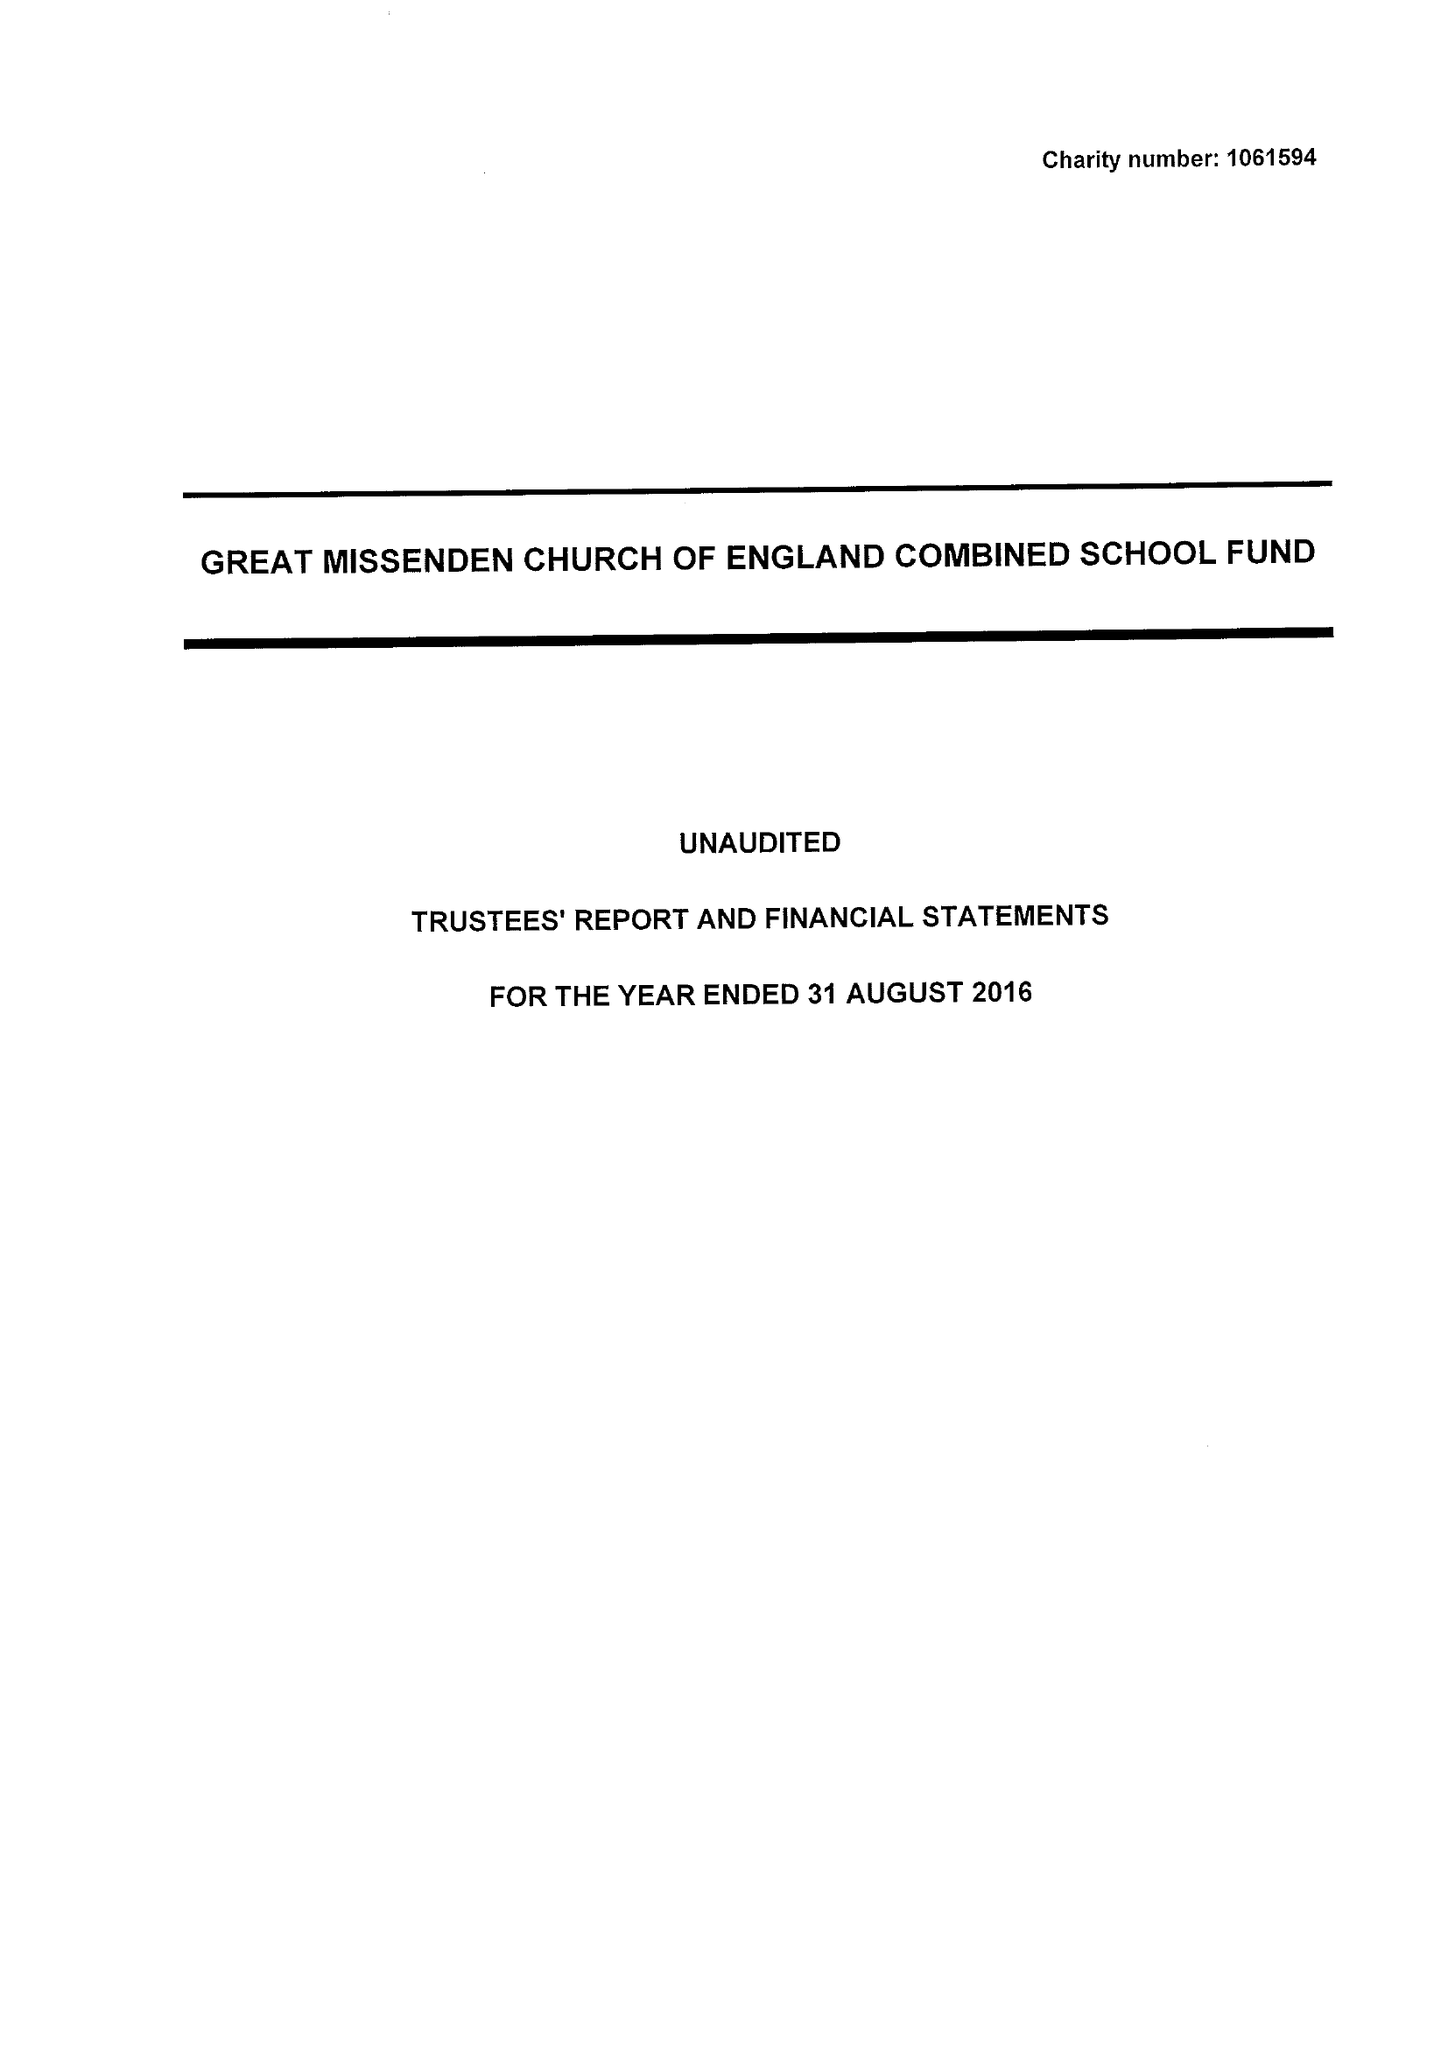What is the value for the charity_name?
Answer the question using a single word or phrase. Great Missenden C Of E Combined School Fund 